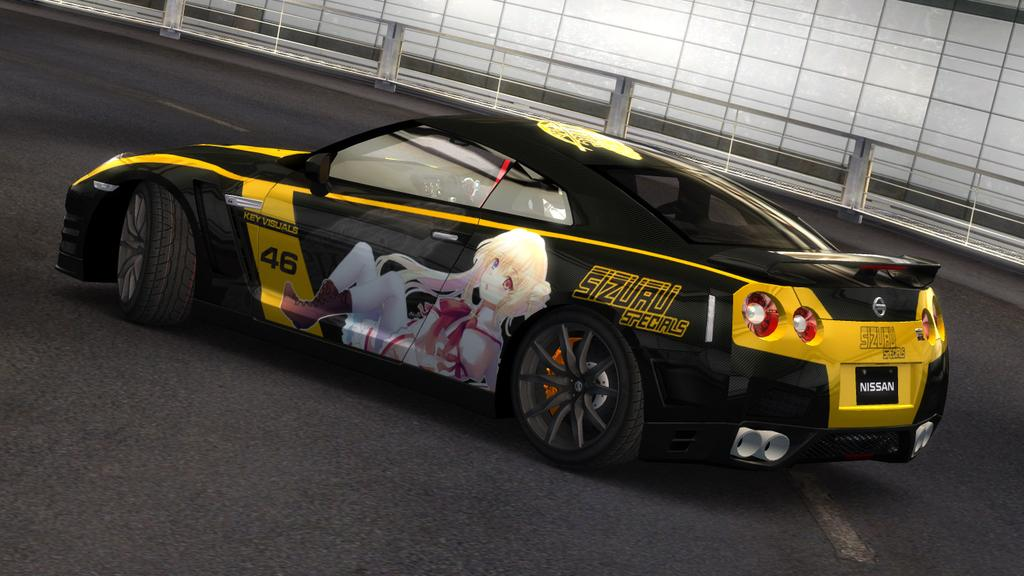What is the main subject of the image? The main subject of the image is a car on the road. What is unique about the car's appearance? The car has a cartoon image of a woman on it. What can be seen in the background of the image? There is fencing and a glass partition visible in the background. How many cakes are on the car's roof in the image? There are no cakes present on the car's roof in the image. 